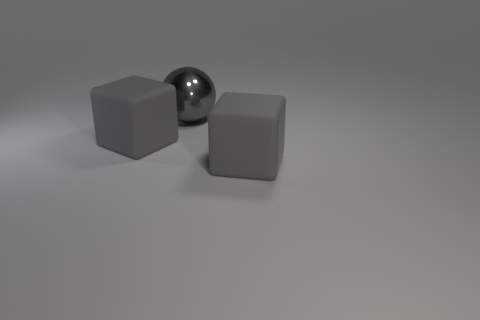Add 3 big gray rubber cubes. How many objects exist? 6 Subtract all blocks. How many objects are left? 1 Subtract 2 blocks. How many blocks are left? 0 Subtract all balls. Subtract all gray spheres. How many objects are left? 1 Add 1 big cubes. How many big cubes are left? 3 Add 2 gray cubes. How many gray cubes exist? 4 Subtract 0 yellow cylinders. How many objects are left? 3 Subtract all blue blocks. Subtract all gray cylinders. How many blocks are left? 2 